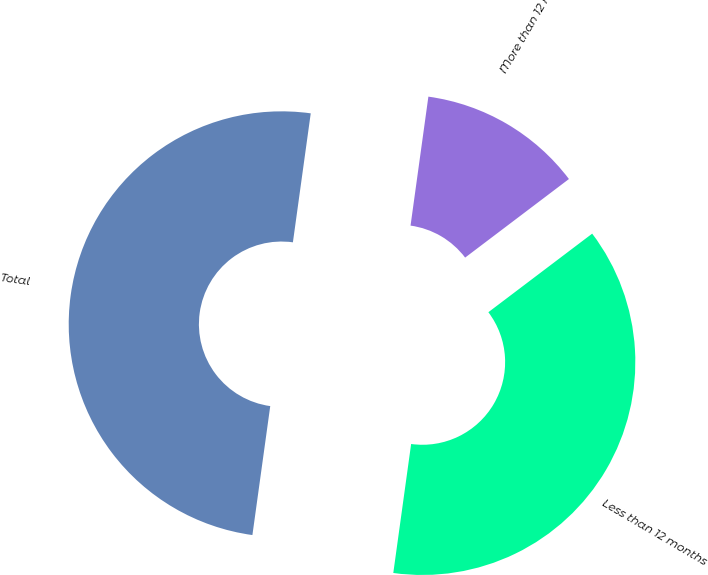Convert chart to OTSL. <chart><loc_0><loc_0><loc_500><loc_500><pie_chart><fcel>Less than 12 months<fcel>More than 12 months<fcel>Total<nl><fcel>37.5%<fcel>12.5%<fcel>50.0%<nl></chart> 